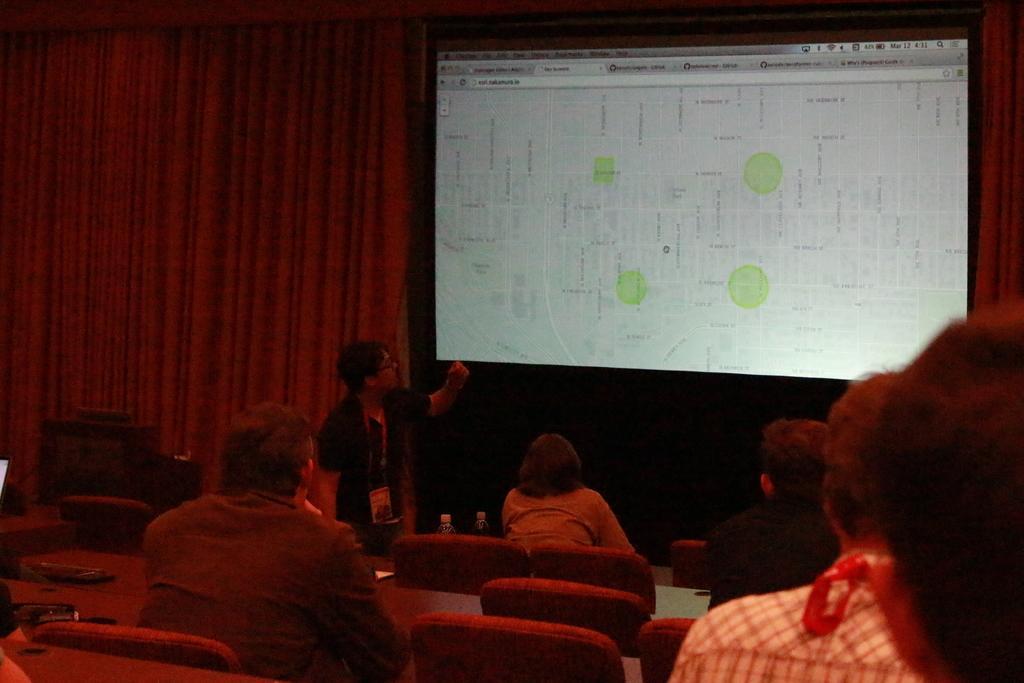Can you describe this image briefly? In this image there are persons sitting and standing and there are empty chairs, there are bottles on the table. In the background there is a screen and there is a curtain which is red in colour and there is a podium. 